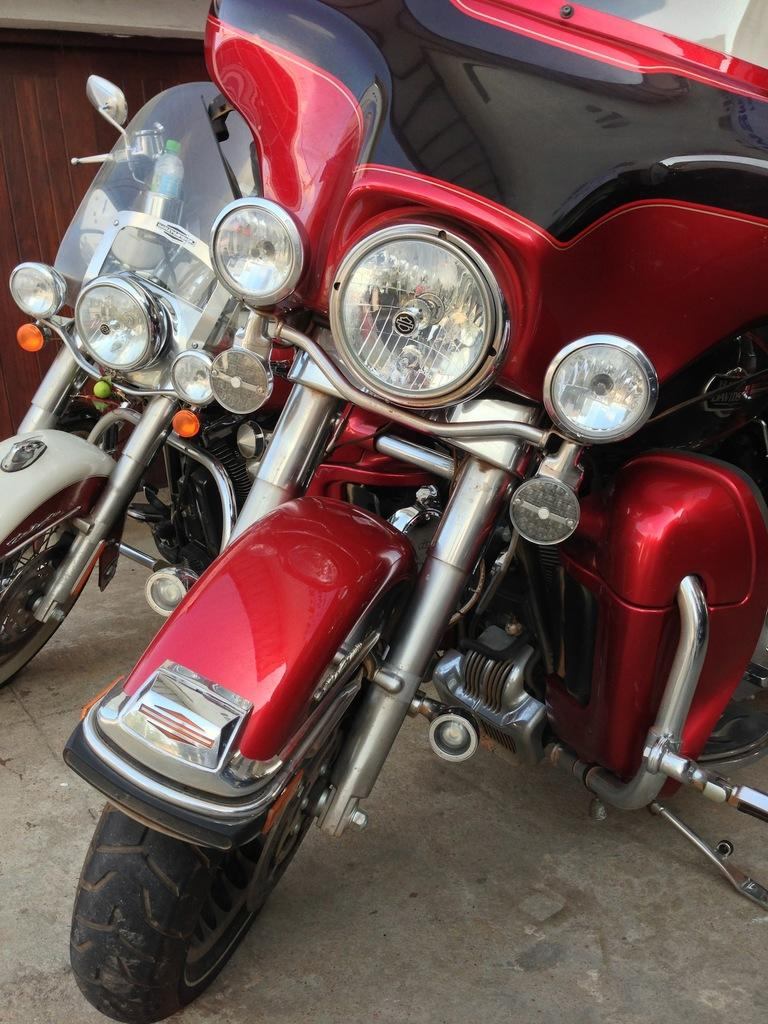How many bikes are in the image? There are two bikes in the image. What features do both bikes have in common? Both bikes have headlights, wheels, stands, and mirrors. What is the color of each bike? One bike is red, and the other is white. What type of cake is being served on the bikes in the image? There is no cake present in the image; it features two bikes with specific features and colors. How many books are stacked on the wheels of the bikes in the image? There are no books present in the image; it only shows two bikes with headlights, wheels, stands, and mirrors. 